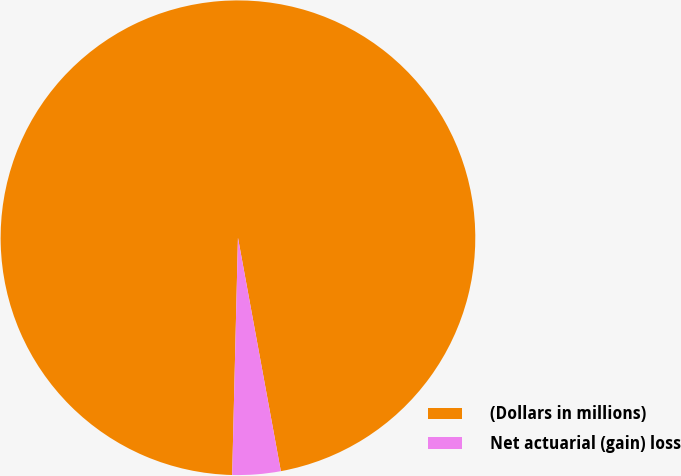Convert chart. <chart><loc_0><loc_0><loc_500><loc_500><pie_chart><fcel>(Dollars in millions)<fcel>Net actuarial (gain) loss<nl><fcel>96.72%<fcel>3.28%<nl></chart> 